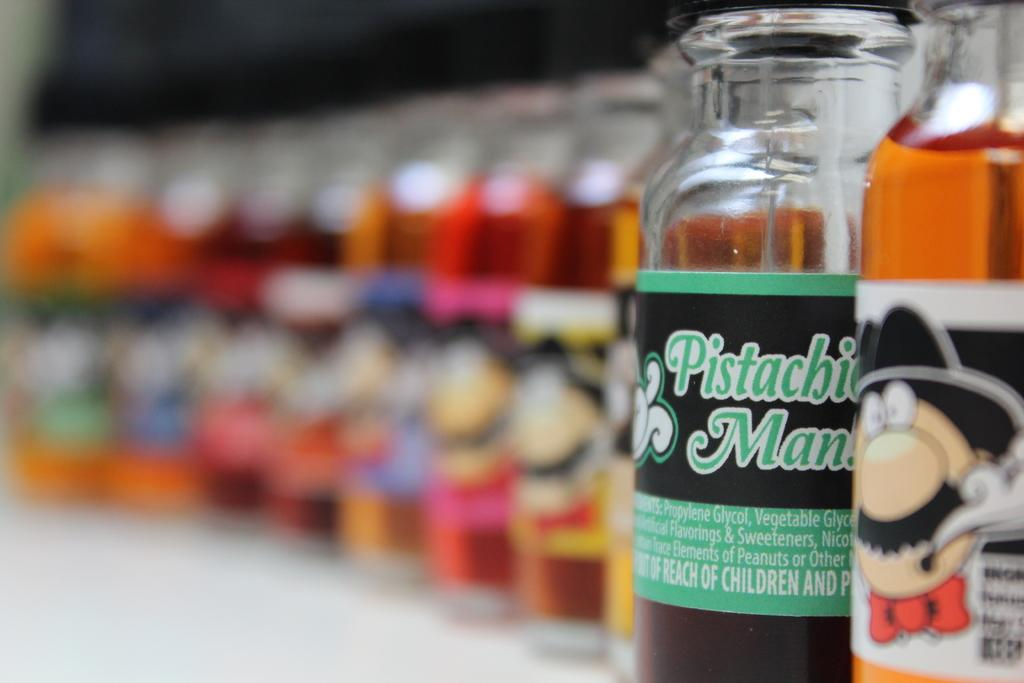What objects can be seen in the image? There are bottles in the image. What is depicted on the bottles? There is an animation character on the bottles. How many hands are visible holding the bottles in the image? There is no information about hands holding the bottles in the image, so we cannot determine the number of hands. 